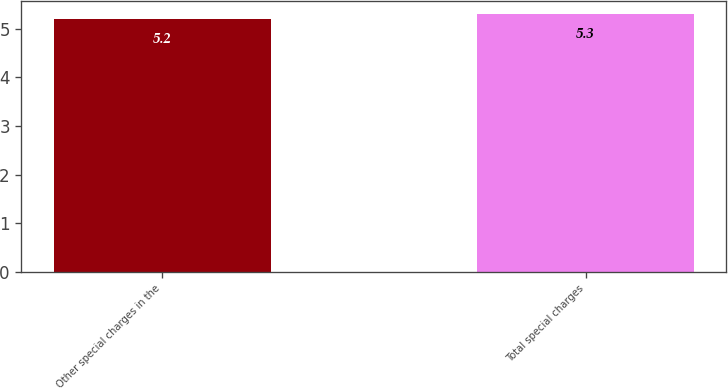Convert chart. <chart><loc_0><loc_0><loc_500><loc_500><bar_chart><fcel>Other special charges in the<fcel>Total special charges<nl><fcel>5.2<fcel>5.3<nl></chart> 